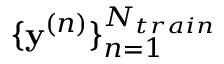Convert formula to latex. <formula><loc_0><loc_0><loc_500><loc_500>\{ y ^ { ( n ) } \} _ { n = 1 } ^ { N _ { t r a i n } }</formula> 